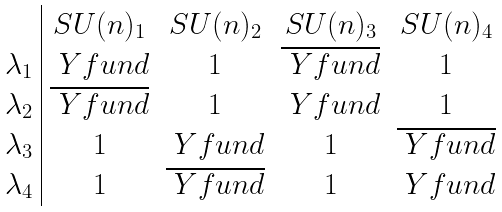<formula> <loc_0><loc_0><loc_500><loc_500>\begin{array} { c | c c c c } & S U ( n ) _ { 1 } & S U ( n ) _ { 2 } & S U ( n ) _ { 3 } & S U ( n ) _ { 4 } \\ \lambda _ { 1 } & \ Y f u n d & 1 & \overline { \ Y f u n d } & 1 \\ \lambda _ { 2 } & \overline { \ Y f u n d } & 1 & \ Y f u n d & 1 \\ \lambda _ { 3 } & 1 & \ Y f u n d & 1 & \overline { \ Y f u n d } \\ \lambda _ { 4 } & 1 & \overline { \ Y f u n d } & 1 & \ Y f u n d \end{array}</formula> 